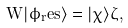Convert formula to latex. <formula><loc_0><loc_0><loc_500><loc_500>W | \phi _ { r } e s \rangle = | \chi \rangle \zeta ,</formula> 